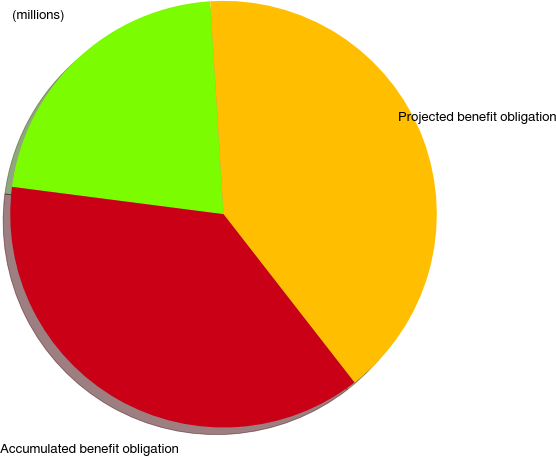Convert chart to OTSL. <chart><loc_0><loc_0><loc_500><loc_500><pie_chart><fcel>(millions)<fcel>Projected benefit obligation<fcel>Accumulated benefit obligation<nl><fcel>21.96%<fcel>40.47%<fcel>37.57%<nl></chart> 